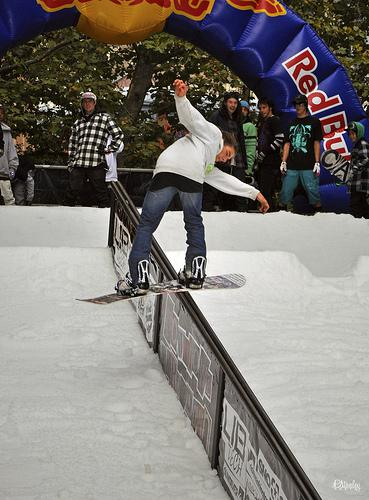Question: when is this event?
Choices:
A. Summer.
B. Spring.
C. Winter.
D. Fall.
Answer with the letter. Answer: C Question: what is he doing?
Choices:
A. Surfing.
B. Skiing.
C. Skating.
D. Snowboarding.
Answer with the letter. Answer: D Question: why is he snowboarding?
Choices:
A. For fun.
B. To kill time.
C. A competition.
D. For recreation.
Answer with the letter. Answer: C Question: how many rails are there?
Choices:
A. One.
B. Two.
C. Four.
D. Eight.
Answer with the letter. Answer: A Question: who is the sponsor?
Choices:
A. Red Bull.
B. Coca Cola.
C. Pepsi.
D. Dr. Pepper.
Answer with the letter. Answer: A 